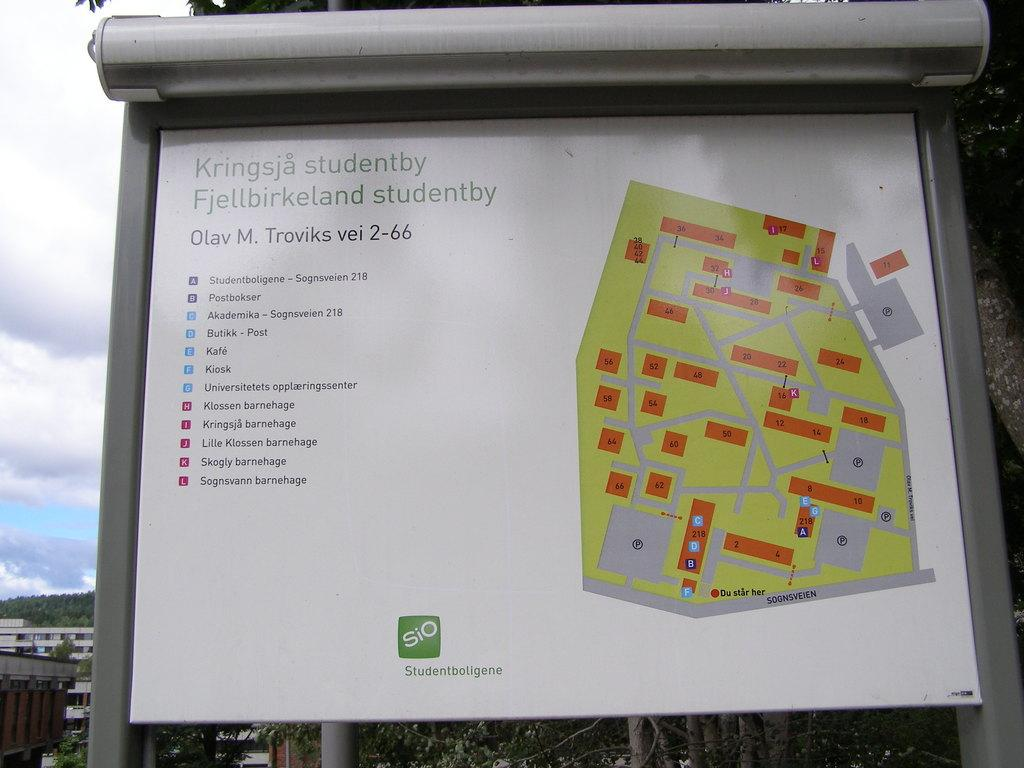<image>
Write a terse but informative summary of the picture. A map billboard for Kringsja studentby Fjellbirkeland studentby. 